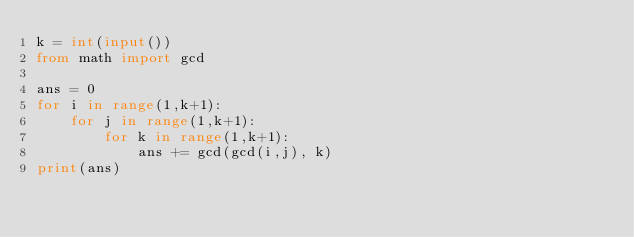<code> <loc_0><loc_0><loc_500><loc_500><_Python_>k = int(input())
from math import gcd

ans = 0
for i in range(1,k+1):
    for j in range(1,k+1):
        for k in range(1,k+1):
            ans += gcd(gcd(i,j), k)
print(ans)</code> 